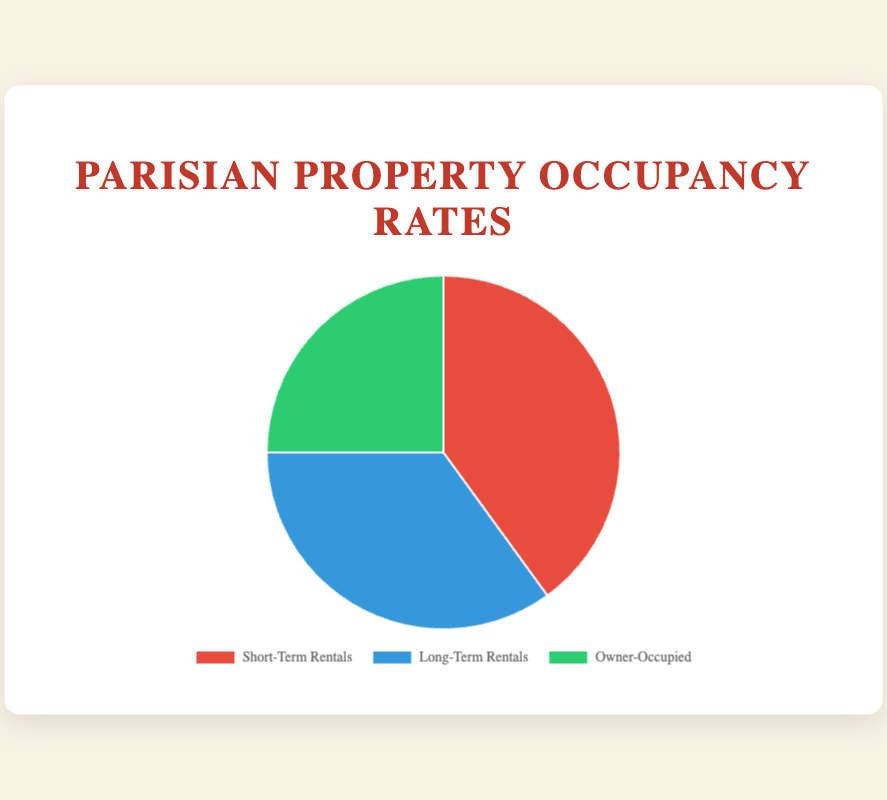What is the occupancy rate of short-term rentals in central Paris? According to the pie chart, the occupancy rate of short-term rentals is represented as 40%. This can be observed directly from the chart's data labels.
Answer: 40% Which type of property has the lowest occupancy rate? The pie chart displays three types of properties, each with their respective occupancy rates. Owner-Occupied properties have the lowest rate at 25%.
Answer: Owner-Occupied How much higher is the occupancy rate for short-term rentals compared to long-term rentals? The occupancy rate for short-term rentals is 40%, while for long-term rentals it is 35%. The difference is calculated as 40% - 35% = 5%.
Answer: 5% Which property type occupies the largest portion of the pie chart, and by how much more percentage than the second-largest? The largest portion of the pie chart is occupied by short-term rentals with 40%. The second-largest is long-term rentals at 35%. The difference between them is 40% - 35% = 5%.
Answer: Short-Term Rentals, 5% What is the combined occupancy rate for owner-occupied and long-term rental properties? The occupancy rates for owner-occupied and long-term rentals are 25% and 35% respectively. The combined rate is 25% + 35% = 60%.
Answer: 60% If the total percentage were to be converted into a fraction, which property type's occupancy rate corresponds to 1/4 of the entire pie chart? The entire pie chart represents 100%. Owner-occupied properties have an occupancy rate of 25%, which is equivalent to 1/4 of 100%.
Answer: Owner-Occupied How does the percentage of long-term rentals compare to the sum of the percentages of the other two property types? The sum of the occupancy rates for short-term rentals (40%) and owner-occupied (25%) is 65%. The occupancy rate of long-term rentals (35%) is less than this sum by 65% - 35% = 30%.
Answer: Less by 30% What percentage of the pie chart is occupied by properties which are not short-term rentals? The properties which are not short-term rentals are long-term rentals and owner-occupied. Their combined occupancy rate is 35% + 25% = 60%.
Answer: 60% What is the difference in occupancy rates between the property type with the highest rate and the one with the lowest rate? The highest occupancy rate is for short-term rentals at 40%, and the lowest is for owner-occupied properties at 25%. The difference is 40% - 25% = 15%.
Answer: 15% Of the three property types, which two have occupancy rates adding up to more than half of the total pie chart, and what is their combined rate? Long-term rentals and short-term rentals have rates of 35% and 40%, respectively. Their combined rate is 35% + 40% = 75%, which is more than half of the total pie (50%).
Answer: Long-Term Rentals and Short-Term Rentals, 75% 